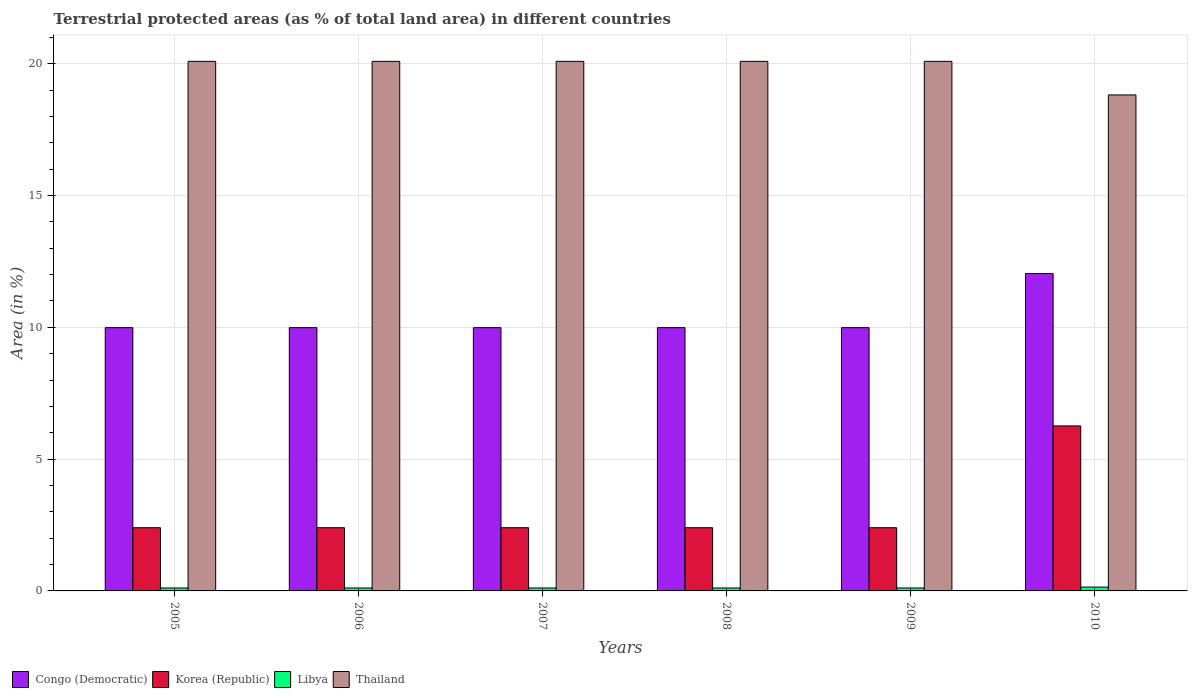How many bars are there on the 6th tick from the left?
Your answer should be compact. 4. How many bars are there on the 2nd tick from the right?
Your answer should be very brief. 4. In how many cases, is the number of bars for a given year not equal to the number of legend labels?
Ensure brevity in your answer.  0. What is the percentage of terrestrial protected land in Thailand in 2008?
Offer a very short reply. 20.09. Across all years, what is the maximum percentage of terrestrial protected land in Congo (Democratic)?
Ensure brevity in your answer.  12.04. Across all years, what is the minimum percentage of terrestrial protected land in Thailand?
Make the answer very short. 18.82. What is the total percentage of terrestrial protected land in Congo (Democratic) in the graph?
Ensure brevity in your answer.  61.98. What is the difference between the percentage of terrestrial protected land in Thailand in 2006 and that in 2010?
Ensure brevity in your answer.  1.27. What is the difference between the percentage of terrestrial protected land in Korea (Republic) in 2009 and the percentage of terrestrial protected land in Libya in 2006?
Give a very brief answer. 2.29. What is the average percentage of terrestrial protected land in Congo (Democratic) per year?
Your response must be concise. 10.33. In the year 2008, what is the difference between the percentage of terrestrial protected land in Congo (Democratic) and percentage of terrestrial protected land in Korea (Republic)?
Give a very brief answer. 7.59. What is the ratio of the percentage of terrestrial protected land in Libya in 2009 to that in 2010?
Make the answer very short. 0.76. Is the percentage of terrestrial protected land in Korea (Republic) in 2005 less than that in 2007?
Provide a short and direct response. No. What is the difference between the highest and the second highest percentage of terrestrial protected land in Korea (Republic)?
Your answer should be compact. 3.86. What is the difference between the highest and the lowest percentage of terrestrial protected land in Libya?
Your answer should be compact. 0.03. In how many years, is the percentage of terrestrial protected land in Congo (Democratic) greater than the average percentage of terrestrial protected land in Congo (Democratic) taken over all years?
Offer a terse response. 1. Is the sum of the percentage of terrestrial protected land in Thailand in 2008 and 2009 greater than the maximum percentage of terrestrial protected land in Korea (Republic) across all years?
Your answer should be compact. Yes. What does the 4th bar from the left in 2008 represents?
Your answer should be very brief. Thailand. What does the 1st bar from the right in 2007 represents?
Your answer should be compact. Thailand. Are all the bars in the graph horizontal?
Make the answer very short. No. How many years are there in the graph?
Provide a succinct answer. 6. Does the graph contain any zero values?
Offer a very short reply. No. What is the title of the graph?
Offer a very short reply. Terrestrial protected areas (as % of total land area) in different countries. Does "Luxembourg" appear as one of the legend labels in the graph?
Give a very brief answer. No. What is the label or title of the Y-axis?
Offer a very short reply. Area (in %). What is the Area (in %) of Congo (Democratic) in 2005?
Offer a very short reply. 9.99. What is the Area (in %) of Korea (Republic) in 2005?
Provide a short and direct response. 2.4. What is the Area (in %) of Libya in 2005?
Your answer should be compact. 0.11. What is the Area (in %) of Thailand in 2005?
Provide a short and direct response. 20.09. What is the Area (in %) of Congo (Democratic) in 2006?
Your answer should be compact. 9.99. What is the Area (in %) of Korea (Republic) in 2006?
Your response must be concise. 2.4. What is the Area (in %) in Libya in 2006?
Offer a terse response. 0.11. What is the Area (in %) of Thailand in 2006?
Provide a succinct answer. 20.09. What is the Area (in %) in Congo (Democratic) in 2007?
Provide a succinct answer. 9.99. What is the Area (in %) in Korea (Republic) in 2007?
Your answer should be compact. 2.4. What is the Area (in %) in Libya in 2007?
Make the answer very short. 0.11. What is the Area (in %) of Thailand in 2007?
Your response must be concise. 20.09. What is the Area (in %) in Congo (Democratic) in 2008?
Ensure brevity in your answer.  9.99. What is the Area (in %) of Korea (Republic) in 2008?
Offer a terse response. 2.4. What is the Area (in %) of Libya in 2008?
Provide a succinct answer. 0.11. What is the Area (in %) in Thailand in 2008?
Make the answer very short. 20.09. What is the Area (in %) in Congo (Democratic) in 2009?
Keep it short and to the point. 9.99. What is the Area (in %) in Korea (Republic) in 2009?
Provide a short and direct response. 2.4. What is the Area (in %) in Libya in 2009?
Give a very brief answer. 0.11. What is the Area (in %) in Thailand in 2009?
Keep it short and to the point. 20.09. What is the Area (in %) in Congo (Democratic) in 2010?
Your answer should be compact. 12.04. What is the Area (in %) in Korea (Republic) in 2010?
Your response must be concise. 6.26. What is the Area (in %) in Libya in 2010?
Provide a short and direct response. 0.15. What is the Area (in %) of Thailand in 2010?
Your answer should be very brief. 18.82. Across all years, what is the maximum Area (in %) in Congo (Democratic)?
Make the answer very short. 12.04. Across all years, what is the maximum Area (in %) of Korea (Republic)?
Your answer should be very brief. 6.26. Across all years, what is the maximum Area (in %) in Libya?
Provide a short and direct response. 0.15. Across all years, what is the maximum Area (in %) in Thailand?
Make the answer very short. 20.09. Across all years, what is the minimum Area (in %) in Congo (Democratic)?
Provide a short and direct response. 9.99. Across all years, what is the minimum Area (in %) in Korea (Republic)?
Your answer should be compact. 2.4. Across all years, what is the minimum Area (in %) in Libya?
Ensure brevity in your answer.  0.11. Across all years, what is the minimum Area (in %) of Thailand?
Give a very brief answer. 18.82. What is the total Area (in %) in Congo (Democratic) in the graph?
Your answer should be compact. 61.98. What is the total Area (in %) of Korea (Republic) in the graph?
Offer a terse response. 18.25. What is the total Area (in %) in Libya in the graph?
Ensure brevity in your answer.  0.7. What is the total Area (in %) of Thailand in the graph?
Provide a succinct answer. 119.27. What is the difference between the Area (in %) of Libya in 2005 and that in 2008?
Provide a succinct answer. 0. What is the difference between the Area (in %) in Thailand in 2005 and that in 2008?
Provide a short and direct response. 0. What is the difference between the Area (in %) in Congo (Democratic) in 2005 and that in 2010?
Ensure brevity in your answer.  -2.05. What is the difference between the Area (in %) of Korea (Republic) in 2005 and that in 2010?
Offer a very short reply. -3.86. What is the difference between the Area (in %) in Libya in 2005 and that in 2010?
Your answer should be very brief. -0.03. What is the difference between the Area (in %) in Thailand in 2005 and that in 2010?
Offer a very short reply. 1.27. What is the difference between the Area (in %) in Congo (Democratic) in 2006 and that in 2007?
Your answer should be very brief. 0. What is the difference between the Area (in %) of Korea (Republic) in 2006 and that in 2007?
Give a very brief answer. 0. What is the difference between the Area (in %) in Libya in 2006 and that in 2007?
Your answer should be compact. 0. What is the difference between the Area (in %) of Thailand in 2006 and that in 2007?
Provide a succinct answer. 0. What is the difference between the Area (in %) in Korea (Republic) in 2006 and that in 2008?
Your answer should be very brief. 0. What is the difference between the Area (in %) in Libya in 2006 and that in 2008?
Your answer should be compact. 0. What is the difference between the Area (in %) of Thailand in 2006 and that in 2008?
Provide a short and direct response. 0. What is the difference between the Area (in %) of Korea (Republic) in 2006 and that in 2009?
Offer a terse response. 0. What is the difference between the Area (in %) of Libya in 2006 and that in 2009?
Provide a short and direct response. 0. What is the difference between the Area (in %) of Congo (Democratic) in 2006 and that in 2010?
Your response must be concise. -2.05. What is the difference between the Area (in %) of Korea (Republic) in 2006 and that in 2010?
Your answer should be very brief. -3.86. What is the difference between the Area (in %) in Libya in 2006 and that in 2010?
Give a very brief answer. -0.03. What is the difference between the Area (in %) of Thailand in 2006 and that in 2010?
Keep it short and to the point. 1.27. What is the difference between the Area (in %) in Libya in 2007 and that in 2008?
Make the answer very short. 0. What is the difference between the Area (in %) of Congo (Democratic) in 2007 and that in 2009?
Your response must be concise. 0. What is the difference between the Area (in %) in Korea (Republic) in 2007 and that in 2009?
Ensure brevity in your answer.  0. What is the difference between the Area (in %) in Libya in 2007 and that in 2009?
Make the answer very short. 0. What is the difference between the Area (in %) of Thailand in 2007 and that in 2009?
Keep it short and to the point. 0. What is the difference between the Area (in %) in Congo (Democratic) in 2007 and that in 2010?
Give a very brief answer. -2.05. What is the difference between the Area (in %) of Korea (Republic) in 2007 and that in 2010?
Your answer should be very brief. -3.86. What is the difference between the Area (in %) in Libya in 2007 and that in 2010?
Your response must be concise. -0.03. What is the difference between the Area (in %) in Thailand in 2007 and that in 2010?
Provide a succinct answer. 1.27. What is the difference between the Area (in %) in Congo (Democratic) in 2008 and that in 2009?
Give a very brief answer. 0. What is the difference between the Area (in %) in Libya in 2008 and that in 2009?
Make the answer very short. 0. What is the difference between the Area (in %) in Thailand in 2008 and that in 2009?
Offer a terse response. 0. What is the difference between the Area (in %) of Congo (Democratic) in 2008 and that in 2010?
Your answer should be compact. -2.05. What is the difference between the Area (in %) of Korea (Republic) in 2008 and that in 2010?
Ensure brevity in your answer.  -3.86. What is the difference between the Area (in %) of Libya in 2008 and that in 2010?
Keep it short and to the point. -0.03. What is the difference between the Area (in %) in Thailand in 2008 and that in 2010?
Provide a succinct answer. 1.27. What is the difference between the Area (in %) in Congo (Democratic) in 2009 and that in 2010?
Your answer should be very brief. -2.05. What is the difference between the Area (in %) in Korea (Republic) in 2009 and that in 2010?
Offer a very short reply. -3.86. What is the difference between the Area (in %) in Libya in 2009 and that in 2010?
Give a very brief answer. -0.03. What is the difference between the Area (in %) of Thailand in 2009 and that in 2010?
Ensure brevity in your answer.  1.27. What is the difference between the Area (in %) in Congo (Democratic) in 2005 and the Area (in %) in Korea (Republic) in 2006?
Offer a very short reply. 7.59. What is the difference between the Area (in %) of Congo (Democratic) in 2005 and the Area (in %) of Libya in 2006?
Offer a very short reply. 9.88. What is the difference between the Area (in %) in Congo (Democratic) in 2005 and the Area (in %) in Thailand in 2006?
Make the answer very short. -10.1. What is the difference between the Area (in %) in Korea (Republic) in 2005 and the Area (in %) in Libya in 2006?
Offer a terse response. 2.29. What is the difference between the Area (in %) in Korea (Republic) in 2005 and the Area (in %) in Thailand in 2006?
Give a very brief answer. -17.69. What is the difference between the Area (in %) in Libya in 2005 and the Area (in %) in Thailand in 2006?
Provide a succinct answer. -19.98. What is the difference between the Area (in %) of Congo (Democratic) in 2005 and the Area (in %) of Korea (Republic) in 2007?
Your answer should be very brief. 7.59. What is the difference between the Area (in %) of Congo (Democratic) in 2005 and the Area (in %) of Libya in 2007?
Your answer should be compact. 9.88. What is the difference between the Area (in %) in Congo (Democratic) in 2005 and the Area (in %) in Thailand in 2007?
Make the answer very short. -10.1. What is the difference between the Area (in %) in Korea (Republic) in 2005 and the Area (in %) in Libya in 2007?
Make the answer very short. 2.29. What is the difference between the Area (in %) in Korea (Republic) in 2005 and the Area (in %) in Thailand in 2007?
Provide a short and direct response. -17.69. What is the difference between the Area (in %) of Libya in 2005 and the Area (in %) of Thailand in 2007?
Offer a terse response. -19.98. What is the difference between the Area (in %) in Congo (Democratic) in 2005 and the Area (in %) in Korea (Republic) in 2008?
Your response must be concise. 7.59. What is the difference between the Area (in %) of Congo (Democratic) in 2005 and the Area (in %) of Libya in 2008?
Keep it short and to the point. 9.88. What is the difference between the Area (in %) in Congo (Democratic) in 2005 and the Area (in %) in Thailand in 2008?
Keep it short and to the point. -10.1. What is the difference between the Area (in %) of Korea (Republic) in 2005 and the Area (in %) of Libya in 2008?
Provide a short and direct response. 2.29. What is the difference between the Area (in %) in Korea (Republic) in 2005 and the Area (in %) in Thailand in 2008?
Ensure brevity in your answer.  -17.69. What is the difference between the Area (in %) of Libya in 2005 and the Area (in %) of Thailand in 2008?
Make the answer very short. -19.98. What is the difference between the Area (in %) in Congo (Democratic) in 2005 and the Area (in %) in Korea (Republic) in 2009?
Your response must be concise. 7.59. What is the difference between the Area (in %) in Congo (Democratic) in 2005 and the Area (in %) in Libya in 2009?
Provide a short and direct response. 9.88. What is the difference between the Area (in %) of Congo (Democratic) in 2005 and the Area (in %) of Thailand in 2009?
Give a very brief answer. -10.1. What is the difference between the Area (in %) in Korea (Republic) in 2005 and the Area (in %) in Libya in 2009?
Ensure brevity in your answer.  2.29. What is the difference between the Area (in %) of Korea (Republic) in 2005 and the Area (in %) of Thailand in 2009?
Give a very brief answer. -17.69. What is the difference between the Area (in %) of Libya in 2005 and the Area (in %) of Thailand in 2009?
Ensure brevity in your answer.  -19.98. What is the difference between the Area (in %) in Congo (Democratic) in 2005 and the Area (in %) in Korea (Republic) in 2010?
Ensure brevity in your answer.  3.73. What is the difference between the Area (in %) of Congo (Democratic) in 2005 and the Area (in %) of Libya in 2010?
Provide a succinct answer. 9.84. What is the difference between the Area (in %) of Congo (Democratic) in 2005 and the Area (in %) of Thailand in 2010?
Ensure brevity in your answer.  -8.83. What is the difference between the Area (in %) of Korea (Republic) in 2005 and the Area (in %) of Libya in 2010?
Provide a short and direct response. 2.25. What is the difference between the Area (in %) in Korea (Republic) in 2005 and the Area (in %) in Thailand in 2010?
Offer a very short reply. -16.42. What is the difference between the Area (in %) of Libya in 2005 and the Area (in %) of Thailand in 2010?
Offer a terse response. -18.7. What is the difference between the Area (in %) of Congo (Democratic) in 2006 and the Area (in %) of Korea (Republic) in 2007?
Ensure brevity in your answer.  7.59. What is the difference between the Area (in %) of Congo (Democratic) in 2006 and the Area (in %) of Libya in 2007?
Your answer should be very brief. 9.88. What is the difference between the Area (in %) of Congo (Democratic) in 2006 and the Area (in %) of Thailand in 2007?
Your answer should be compact. -10.1. What is the difference between the Area (in %) of Korea (Republic) in 2006 and the Area (in %) of Libya in 2007?
Ensure brevity in your answer.  2.29. What is the difference between the Area (in %) in Korea (Republic) in 2006 and the Area (in %) in Thailand in 2007?
Your response must be concise. -17.69. What is the difference between the Area (in %) of Libya in 2006 and the Area (in %) of Thailand in 2007?
Your answer should be compact. -19.98. What is the difference between the Area (in %) in Congo (Democratic) in 2006 and the Area (in %) in Korea (Republic) in 2008?
Ensure brevity in your answer.  7.59. What is the difference between the Area (in %) of Congo (Democratic) in 2006 and the Area (in %) of Libya in 2008?
Ensure brevity in your answer.  9.88. What is the difference between the Area (in %) of Congo (Democratic) in 2006 and the Area (in %) of Thailand in 2008?
Provide a short and direct response. -10.1. What is the difference between the Area (in %) in Korea (Republic) in 2006 and the Area (in %) in Libya in 2008?
Offer a terse response. 2.29. What is the difference between the Area (in %) of Korea (Republic) in 2006 and the Area (in %) of Thailand in 2008?
Offer a terse response. -17.69. What is the difference between the Area (in %) of Libya in 2006 and the Area (in %) of Thailand in 2008?
Your answer should be compact. -19.98. What is the difference between the Area (in %) in Congo (Democratic) in 2006 and the Area (in %) in Korea (Republic) in 2009?
Give a very brief answer. 7.59. What is the difference between the Area (in %) of Congo (Democratic) in 2006 and the Area (in %) of Libya in 2009?
Make the answer very short. 9.88. What is the difference between the Area (in %) of Congo (Democratic) in 2006 and the Area (in %) of Thailand in 2009?
Provide a succinct answer. -10.1. What is the difference between the Area (in %) in Korea (Republic) in 2006 and the Area (in %) in Libya in 2009?
Make the answer very short. 2.29. What is the difference between the Area (in %) in Korea (Republic) in 2006 and the Area (in %) in Thailand in 2009?
Make the answer very short. -17.69. What is the difference between the Area (in %) of Libya in 2006 and the Area (in %) of Thailand in 2009?
Give a very brief answer. -19.98. What is the difference between the Area (in %) of Congo (Democratic) in 2006 and the Area (in %) of Korea (Republic) in 2010?
Your response must be concise. 3.73. What is the difference between the Area (in %) in Congo (Democratic) in 2006 and the Area (in %) in Libya in 2010?
Offer a very short reply. 9.84. What is the difference between the Area (in %) in Congo (Democratic) in 2006 and the Area (in %) in Thailand in 2010?
Make the answer very short. -8.83. What is the difference between the Area (in %) in Korea (Republic) in 2006 and the Area (in %) in Libya in 2010?
Make the answer very short. 2.25. What is the difference between the Area (in %) of Korea (Republic) in 2006 and the Area (in %) of Thailand in 2010?
Your response must be concise. -16.42. What is the difference between the Area (in %) of Libya in 2006 and the Area (in %) of Thailand in 2010?
Provide a succinct answer. -18.7. What is the difference between the Area (in %) in Congo (Democratic) in 2007 and the Area (in %) in Korea (Republic) in 2008?
Your answer should be very brief. 7.59. What is the difference between the Area (in %) in Congo (Democratic) in 2007 and the Area (in %) in Libya in 2008?
Offer a terse response. 9.88. What is the difference between the Area (in %) in Congo (Democratic) in 2007 and the Area (in %) in Thailand in 2008?
Your response must be concise. -10.1. What is the difference between the Area (in %) in Korea (Republic) in 2007 and the Area (in %) in Libya in 2008?
Provide a succinct answer. 2.29. What is the difference between the Area (in %) in Korea (Republic) in 2007 and the Area (in %) in Thailand in 2008?
Ensure brevity in your answer.  -17.69. What is the difference between the Area (in %) of Libya in 2007 and the Area (in %) of Thailand in 2008?
Give a very brief answer. -19.98. What is the difference between the Area (in %) of Congo (Democratic) in 2007 and the Area (in %) of Korea (Republic) in 2009?
Offer a terse response. 7.59. What is the difference between the Area (in %) in Congo (Democratic) in 2007 and the Area (in %) in Libya in 2009?
Offer a very short reply. 9.88. What is the difference between the Area (in %) in Congo (Democratic) in 2007 and the Area (in %) in Thailand in 2009?
Give a very brief answer. -10.1. What is the difference between the Area (in %) in Korea (Republic) in 2007 and the Area (in %) in Libya in 2009?
Your response must be concise. 2.29. What is the difference between the Area (in %) of Korea (Republic) in 2007 and the Area (in %) of Thailand in 2009?
Give a very brief answer. -17.69. What is the difference between the Area (in %) of Libya in 2007 and the Area (in %) of Thailand in 2009?
Keep it short and to the point. -19.98. What is the difference between the Area (in %) in Congo (Democratic) in 2007 and the Area (in %) in Korea (Republic) in 2010?
Offer a terse response. 3.73. What is the difference between the Area (in %) of Congo (Democratic) in 2007 and the Area (in %) of Libya in 2010?
Ensure brevity in your answer.  9.84. What is the difference between the Area (in %) of Congo (Democratic) in 2007 and the Area (in %) of Thailand in 2010?
Offer a very short reply. -8.83. What is the difference between the Area (in %) in Korea (Republic) in 2007 and the Area (in %) in Libya in 2010?
Offer a very short reply. 2.25. What is the difference between the Area (in %) of Korea (Republic) in 2007 and the Area (in %) of Thailand in 2010?
Offer a terse response. -16.42. What is the difference between the Area (in %) of Libya in 2007 and the Area (in %) of Thailand in 2010?
Offer a very short reply. -18.7. What is the difference between the Area (in %) in Congo (Democratic) in 2008 and the Area (in %) in Korea (Republic) in 2009?
Keep it short and to the point. 7.59. What is the difference between the Area (in %) of Congo (Democratic) in 2008 and the Area (in %) of Libya in 2009?
Your answer should be compact. 9.88. What is the difference between the Area (in %) of Congo (Democratic) in 2008 and the Area (in %) of Thailand in 2009?
Your answer should be compact. -10.1. What is the difference between the Area (in %) in Korea (Republic) in 2008 and the Area (in %) in Libya in 2009?
Provide a short and direct response. 2.29. What is the difference between the Area (in %) of Korea (Republic) in 2008 and the Area (in %) of Thailand in 2009?
Offer a very short reply. -17.69. What is the difference between the Area (in %) of Libya in 2008 and the Area (in %) of Thailand in 2009?
Offer a very short reply. -19.98. What is the difference between the Area (in %) of Congo (Democratic) in 2008 and the Area (in %) of Korea (Republic) in 2010?
Give a very brief answer. 3.73. What is the difference between the Area (in %) of Congo (Democratic) in 2008 and the Area (in %) of Libya in 2010?
Ensure brevity in your answer.  9.84. What is the difference between the Area (in %) in Congo (Democratic) in 2008 and the Area (in %) in Thailand in 2010?
Provide a short and direct response. -8.83. What is the difference between the Area (in %) of Korea (Republic) in 2008 and the Area (in %) of Libya in 2010?
Give a very brief answer. 2.25. What is the difference between the Area (in %) in Korea (Republic) in 2008 and the Area (in %) in Thailand in 2010?
Provide a succinct answer. -16.42. What is the difference between the Area (in %) in Libya in 2008 and the Area (in %) in Thailand in 2010?
Your answer should be compact. -18.7. What is the difference between the Area (in %) of Congo (Democratic) in 2009 and the Area (in %) of Korea (Republic) in 2010?
Provide a succinct answer. 3.73. What is the difference between the Area (in %) in Congo (Democratic) in 2009 and the Area (in %) in Libya in 2010?
Your answer should be compact. 9.84. What is the difference between the Area (in %) of Congo (Democratic) in 2009 and the Area (in %) of Thailand in 2010?
Provide a short and direct response. -8.83. What is the difference between the Area (in %) in Korea (Republic) in 2009 and the Area (in %) in Libya in 2010?
Make the answer very short. 2.25. What is the difference between the Area (in %) in Korea (Republic) in 2009 and the Area (in %) in Thailand in 2010?
Your answer should be very brief. -16.42. What is the difference between the Area (in %) in Libya in 2009 and the Area (in %) in Thailand in 2010?
Provide a succinct answer. -18.7. What is the average Area (in %) in Congo (Democratic) per year?
Your answer should be very brief. 10.33. What is the average Area (in %) of Korea (Republic) per year?
Provide a succinct answer. 3.04. What is the average Area (in %) of Libya per year?
Make the answer very short. 0.12. What is the average Area (in %) of Thailand per year?
Your answer should be very brief. 19.88. In the year 2005, what is the difference between the Area (in %) in Congo (Democratic) and Area (in %) in Korea (Republic)?
Provide a short and direct response. 7.59. In the year 2005, what is the difference between the Area (in %) in Congo (Democratic) and Area (in %) in Libya?
Offer a terse response. 9.88. In the year 2005, what is the difference between the Area (in %) of Congo (Democratic) and Area (in %) of Thailand?
Provide a succinct answer. -10.1. In the year 2005, what is the difference between the Area (in %) of Korea (Republic) and Area (in %) of Libya?
Ensure brevity in your answer.  2.29. In the year 2005, what is the difference between the Area (in %) in Korea (Republic) and Area (in %) in Thailand?
Ensure brevity in your answer.  -17.69. In the year 2005, what is the difference between the Area (in %) of Libya and Area (in %) of Thailand?
Your answer should be very brief. -19.98. In the year 2006, what is the difference between the Area (in %) in Congo (Democratic) and Area (in %) in Korea (Republic)?
Offer a terse response. 7.59. In the year 2006, what is the difference between the Area (in %) in Congo (Democratic) and Area (in %) in Libya?
Keep it short and to the point. 9.88. In the year 2006, what is the difference between the Area (in %) in Congo (Democratic) and Area (in %) in Thailand?
Offer a terse response. -10.1. In the year 2006, what is the difference between the Area (in %) in Korea (Republic) and Area (in %) in Libya?
Make the answer very short. 2.29. In the year 2006, what is the difference between the Area (in %) of Korea (Republic) and Area (in %) of Thailand?
Give a very brief answer. -17.69. In the year 2006, what is the difference between the Area (in %) of Libya and Area (in %) of Thailand?
Provide a short and direct response. -19.98. In the year 2007, what is the difference between the Area (in %) of Congo (Democratic) and Area (in %) of Korea (Republic)?
Provide a succinct answer. 7.59. In the year 2007, what is the difference between the Area (in %) in Congo (Democratic) and Area (in %) in Libya?
Your answer should be very brief. 9.88. In the year 2007, what is the difference between the Area (in %) of Congo (Democratic) and Area (in %) of Thailand?
Ensure brevity in your answer.  -10.1. In the year 2007, what is the difference between the Area (in %) of Korea (Republic) and Area (in %) of Libya?
Give a very brief answer. 2.29. In the year 2007, what is the difference between the Area (in %) in Korea (Republic) and Area (in %) in Thailand?
Offer a terse response. -17.69. In the year 2007, what is the difference between the Area (in %) in Libya and Area (in %) in Thailand?
Your answer should be compact. -19.98. In the year 2008, what is the difference between the Area (in %) of Congo (Democratic) and Area (in %) of Korea (Republic)?
Provide a short and direct response. 7.59. In the year 2008, what is the difference between the Area (in %) of Congo (Democratic) and Area (in %) of Libya?
Provide a succinct answer. 9.88. In the year 2008, what is the difference between the Area (in %) in Congo (Democratic) and Area (in %) in Thailand?
Give a very brief answer. -10.1. In the year 2008, what is the difference between the Area (in %) in Korea (Republic) and Area (in %) in Libya?
Ensure brevity in your answer.  2.29. In the year 2008, what is the difference between the Area (in %) in Korea (Republic) and Area (in %) in Thailand?
Provide a short and direct response. -17.69. In the year 2008, what is the difference between the Area (in %) of Libya and Area (in %) of Thailand?
Your answer should be very brief. -19.98. In the year 2009, what is the difference between the Area (in %) of Congo (Democratic) and Area (in %) of Korea (Republic)?
Your answer should be very brief. 7.59. In the year 2009, what is the difference between the Area (in %) of Congo (Democratic) and Area (in %) of Libya?
Your answer should be very brief. 9.88. In the year 2009, what is the difference between the Area (in %) of Congo (Democratic) and Area (in %) of Thailand?
Ensure brevity in your answer.  -10.1. In the year 2009, what is the difference between the Area (in %) of Korea (Republic) and Area (in %) of Libya?
Keep it short and to the point. 2.29. In the year 2009, what is the difference between the Area (in %) in Korea (Republic) and Area (in %) in Thailand?
Offer a very short reply. -17.69. In the year 2009, what is the difference between the Area (in %) of Libya and Area (in %) of Thailand?
Keep it short and to the point. -19.98. In the year 2010, what is the difference between the Area (in %) in Congo (Democratic) and Area (in %) in Korea (Republic)?
Your answer should be compact. 5.78. In the year 2010, what is the difference between the Area (in %) in Congo (Democratic) and Area (in %) in Libya?
Give a very brief answer. 11.89. In the year 2010, what is the difference between the Area (in %) in Congo (Democratic) and Area (in %) in Thailand?
Your answer should be compact. -6.78. In the year 2010, what is the difference between the Area (in %) in Korea (Republic) and Area (in %) in Libya?
Give a very brief answer. 6.11. In the year 2010, what is the difference between the Area (in %) in Korea (Republic) and Area (in %) in Thailand?
Offer a terse response. -12.56. In the year 2010, what is the difference between the Area (in %) in Libya and Area (in %) in Thailand?
Give a very brief answer. -18.67. What is the ratio of the Area (in %) in Congo (Democratic) in 2005 to that in 2006?
Offer a terse response. 1. What is the ratio of the Area (in %) in Korea (Republic) in 2005 to that in 2006?
Keep it short and to the point. 1. What is the ratio of the Area (in %) in Thailand in 2005 to that in 2006?
Ensure brevity in your answer.  1. What is the ratio of the Area (in %) of Congo (Democratic) in 2005 to that in 2007?
Make the answer very short. 1. What is the ratio of the Area (in %) of Korea (Republic) in 2005 to that in 2007?
Make the answer very short. 1. What is the ratio of the Area (in %) of Libya in 2005 to that in 2007?
Provide a short and direct response. 1. What is the ratio of the Area (in %) in Congo (Democratic) in 2005 to that in 2008?
Provide a succinct answer. 1. What is the ratio of the Area (in %) of Congo (Democratic) in 2005 to that in 2009?
Make the answer very short. 1. What is the ratio of the Area (in %) in Korea (Republic) in 2005 to that in 2009?
Keep it short and to the point. 1. What is the ratio of the Area (in %) of Libya in 2005 to that in 2009?
Provide a short and direct response. 1. What is the ratio of the Area (in %) in Thailand in 2005 to that in 2009?
Provide a short and direct response. 1. What is the ratio of the Area (in %) in Congo (Democratic) in 2005 to that in 2010?
Offer a terse response. 0.83. What is the ratio of the Area (in %) in Korea (Republic) in 2005 to that in 2010?
Offer a terse response. 0.38. What is the ratio of the Area (in %) in Libya in 2005 to that in 2010?
Your answer should be very brief. 0.76. What is the ratio of the Area (in %) of Thailand in 2005 to that in 2010?
Your response must be concise. 1.07. What is the ratio of the Area (in %) in Korea (Republic) in 2006 to that in 2007?
Your answer should be very brief. 1. What is the ratio of the Area (in %) of Libya in 2006 to that in 2007?
Make the answer very short. 1. What is the ratio of the Area (in %) of Thailand in 2006 to that in 2008?
Offer a very short reply. 1. What is the ratio of the Area (in %) of Congo (Democratic) in 2006 to that in 2009?
Offer a terse response. 1. What is the ratio of the Area (in %) of Korea (Republic) in 2006 to that in 2009?
Offer a very short reply. 1. What is the ratio of the Area (in %) of Libya in 2006 to that in 2009?
Your response must be concise. 1. What is the ratio of the Area (in %) in Congo (Democratic) in 2006 to that in 2010?
Make the answer very short. 0.83. What is the ratio of the Area (in %) of Korea (Republic) in 2006 to that in 2010?
Make the answer very short. 0.38. What is the ratio of the Area (in %) of Libya in 2006 to that in 2010?
Offer a very short reply. 0.76. What is the ratio of the Area (in %) of Thailand in 2006 to that in 2010?
Provide a succinct answer. 1.07. What is the ratio of the Area (in %) in Congo (Democratic) in 2007 to that in 2008?
Offer a very short reply. 1. What is the ratio of the Area (in %) in Libya in 2007 to that in 2008?
Offer a terse response. 1. What is the ratio of the Area (in %) in Thailand in 2007 to that in 2008?
Offer a terse response. 1. What is the ratio of the Area (in %) of Congo (Democratic) in 2007 to that in 2009?
Ensure brevity in your answer.  1. What is the ratio of the Area (in %) in Congo (Democratic) in 2007 to that in 2010?
Provide a short and direct response. 0.83. What is the ratio of the Area (in %) of Korea (Republic) in 2007 to that in 2010?
Your response must be concise. 0.38. What is the ratio of the Area (in %) in Libya in 2007 to that in 2010?
Offer a very short reply. 0.76. What is the ratio of the Area (in %) in Thailand in 2007 to that in 2010?
Provide a short and direct response. 1.07. What is the ratio of the Area (in %) of Congo (Democratic) in 2008 to that in 2009?
Give a very brief answer. 1. What is the ratio of the Area (in %) of Korea (Republic) in 2008 to that in 2009?
Keep it short and to the point. 1. What is the ratio of the Area (in %) in Congo (Democratic) in 2008 to that in 2010?
Your answer should be very brief. 0.83. What is the ratio of the Area (in %) in Korea (Republic) in 2008 to that in 2010?
Make the answer very short. 0.38. What is the ratio of the Area (in %) in Libya in 2008 to that in 2010?
Offer a terse response. 0.76. What is the ratio of the Area (in %) in Thailand in 2008 to that in 2010?
Your response must be concise. 1.07. What is the ratio of the Area (in %) in Congo (Democratic) in 2009 to that in 2010?
Your response must be concise. 0.83. What is the ratio of the Area (in %) in Korea (Republic) in 2009 to that in 2010?
Provide a short and direct response. 0.38. What is the ratio of the Area (in %) of Libya in 2009 to that in 2010?
Make the answer very short. 0.76. What is the ratio of the Area (in %) of Thailand in 2009 to that in 2010?
Provide a short and direct response. 1.07. What is the difference between the highest and the second highest Area (in %) of Congo (Democratic)?
Provide a short and direct response. 2.05. What is the difference between the highest and the second highest Area (in %) in Korea (Republic)?
Offer a very short reply. 3.86. What is the difference between the highest and the second highest Area (in %) of Libya?
Offer a terse response. 0.03. What is the difference between the highest and the second highest Area (in %) in Thailand?
Keep it short and to the point. 0. What is the difference between the highest and the lowest Area (in %) in Congo (Democratic)?
Offer a very short reply. 2.05. What is the difference between the highest and the lowest Area (in %) in Korea (Republic)?
Offer a terse response. 3.86. What is the difference between the highest and the lowest Area (in %) in Libya?
Your answer should be very brief. 0.03. What is the difference between the highest and the lowest Area (in %) in Thailand?
Offer a very short reply. 1.27. 